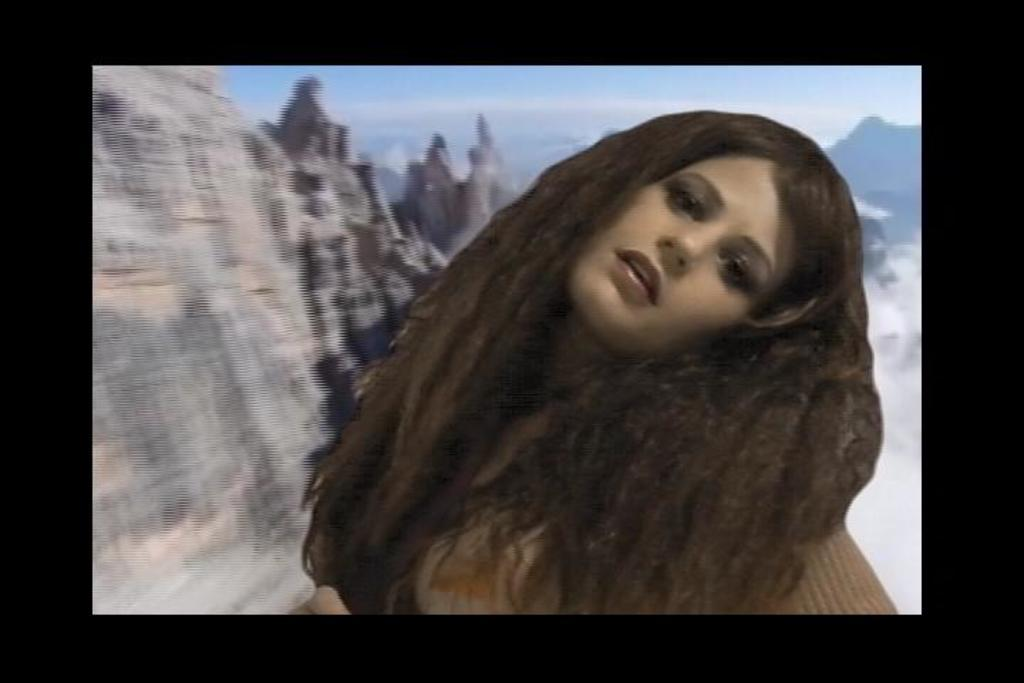What type of picture is in the image? The image contains an edited picture. Who is the main subject in the image? There is a woman in the front side of the image. What can be seen in the background of the image? There are hills visible behind the woman. What is visible at the top of the image? The sky is visible at the top of the image. How many rabbits can be seen playing in the hills in the image? There are no rabbits visible in the image; it features a woman in front of hills with a visible sky. What is the plot of the story behind the woman in the image? The image does not depict a story or plot; it is a single edited picture of a woman in front of hills with a visible sky. 